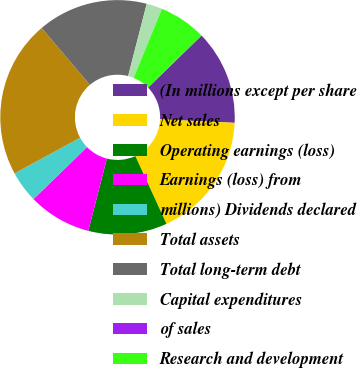Convert chart to OTSL. <chart><loc_0><loc_0><loc_500><loc_500><pie_chart><fcel>(In millions except per share<fcel>Net sales<fcel>Operating earnings (loss)<fcel>Earnings (loss) from<fcel>millions) Dividends declared<fcel>Total assets<fcel>Total long-term debt<fcel>Capital expenditures<fcel>of sales<fcel>Research and development<nl><fcel>13.04%<fcel>17.39%<fcel>10.87%<fcel>8.7%<fcel>4.35%<fcel>21.73%<fcel>15.21%<fcel>2.18%<fcel>0.0%<fcel>6.52%<nl></chart> 